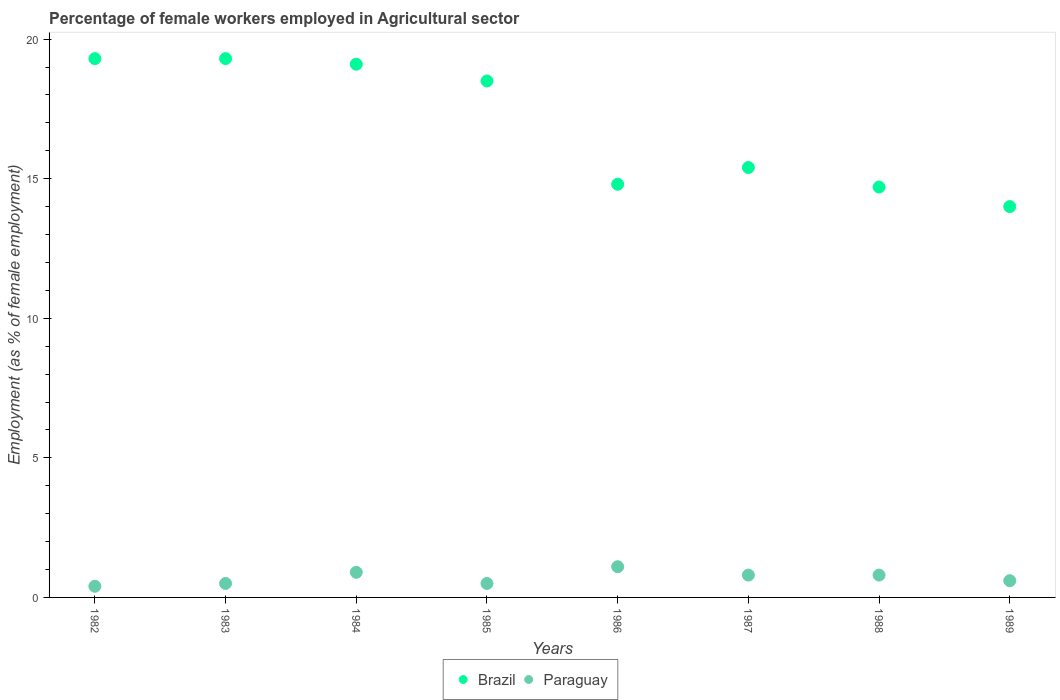How many different coloured dotlines are there?
Your response must be concise. 2. What is the percentage of females employed in Agricultural sector in Paraguay in 1985?
Keep it short and to the point. 0.5. Across all years, what is the maximum percentage of females employed in Agricultural sector in Paraguay?
Your answer should be compact. 1.1. Across all years, what is the minimum percentage of females employed in Agricultural sector in Paraguay?
Provide a short and direct response. 0.4. In which year was the percentage of females employed in Agricultural sector in Paraguay minimum?
Your answer should be compact. 1982. What is the total percentage of females employed in Agricultural sector in Paraguay in the graph?
Give a very brief answer. 5.6. What is the difference between the percentage of females employed in Agricultural sector in Paraguay in 1985 and that in 1988?
Ensure brevity in your answer.  -0.3. What is the difference between the percentage of females employed in Agricultural sector in Brazil in 1989 and the percentage of females employed in Agricultural sector in Paraguay in 1987?
Make the answer very short. 13.2. What is the average percentage of females employed in Agricultural sector in Paraguay per year?
Give a very brief answer. 0.7. In the year 1984, what is the difference between the percentage of females employed in Agricultural sector in Paraguay and percentage of females employed in Agricultural sector in Brazil?
Ensure brevity in your answer.  -18.2. In how many years, is the percentage of females employed in Agricultural sector in Brazil greater than 17 %?
Keep it short and to the point. 4. What is the ratio of the percentage of females employed in Agricultural sector in Paraguay in 1982 to that in 1985?
Offer a very short reply. 0.8. What is the difference between the highest and the second highest percentage of females employed in Agricultural sector in Paraguay?
Give a very brief answer. 0.2. What is the difference between the highest and the lowest percentage of females employed in Agricultural sector in Brazil?
Your answer should be very brief. 5.3. In how many years, is the percentage of females employed in Agricultural sector in Brazil greater than the average percentage of females employed in Agricultural sector in Brazil taken over all years?
Your answer should be compact. 4. Is the sum of the percentage of females employed in Agricultural sector in Brazil in 1984 and 1985 greater than the maximum percentage of females employed in Agricultural sector in Paraguay across all years?
Make the answer very short. Yes. What is the difference between two consecutive major ticks on the Y-axis?
Your response must be concise. 5. Does the graph contain any zero values?
Your response must be concise. No. Does the graph contain grids?
Provide a succinct answer. No. Where does the legend appear in the graph?
Make the answer very short. Bottom center. How are the legend labels stacked?
Your answer should be very brief. Horizontal. What is the title of the graph?
Provide a short and direct response. Percentage of female workers employed in Agricultural sector. What is the label or title of the X-axis?
Your answer should be very brief. Years. What is the label or title of the Y-axis?
Provide a succinct answer. Employment (as % of female employment). What is the Employment (as % of female employment) of Brazil in 1982?
Ensure brevity in your answer.  19.3. What is the Employment (as % of female employment) of Paraguay in 1982?
Offer a terse response. 0.4. What is the Employment (as % of female employment) of Brazil in 1983?
Make the answer very short. 19.3. What is the Employment (as % of female employment) of Paraguay in 1983?
Provide a succinct answer. 0.5. What is the Employment (as % of female employment) in Brazil in 1984?
Offer a very short reply. 19.1. What is the Employment (as % of female employment) in Paraguay in 1984?
Provide a short and direct response. 0.9. What is the Employment (as % of female employment) in Brazil in 1986?
Provide a short and direct response. 14.8. What is the Employment (as % of female employment) of Paraguay in 1986?
Your answer should be very brief. 1.1. What is the Employment (as % of female employment) of Brazil in 1987?
Offer a very short reply. 15.4. What is the Employment (as % of female employment) in Paraguay in 1987?
Give a very brief answer. 0.8. What is the Employment (as % of female employment) in Brazil in 1988?
Your response must be concise. 14.7. What is the Employment (as % of female employment) of Paraguay in 1988?
Provide a short and direct response. 0.8. What is the Employment (as % of female employment) in Brazil in 1989?
Ensure brevity in your answer.  14. What is the Employment (as % of female employment) of Paraguay in 1989?
Offer a very short reply. 0.6. Across all years, what is the maximum Employment (as % of female employment) in Brazil?
Offer a terse response. 19.3. Across all years, what is the maximum Employment (as % of female employment) of Paraguay?
Provide a succinct answer. 1.1. Across all years, what is the minimum Employment (as % of female employment) in Brazil?
Provide a succinct answer. 14. Across all years, what is the minimum Employment (as % of female employment) of Paraguay?
Your answer should be very brief. 0.4. What is the total Employment (as % of female employment) in Brazil in the graph?
Ensure brevity in your answer.  135.1. What is the difference between the Employment (as % of female employment) in Brazil in 1982 and that in 1983?
Keep it short and to the point. 0. What is the difference between the Employment (as % of female employment) in Paraguay in 1982 and that in 1983?
Your answer should be compact. -0.1. What is the difference between the Employment (as % of female employment) of Brazil in 1982 and that in 1984?
Your answer should be compact. 0.2. What is the difference between the Employment (as % of female employment) in Paraguay in 1982 and that in 1984?
Offer a very short reply. -0.5. What is the difference between the Employment (as % of female employment) of Brazil in 1982 and that in 1985?
Give a very brief answer. 0.8. What is the difference between the Employment (as % of female employment) of Paraguay in 1982 and that in 1985?
Keep it short and to the point. -0.1. What is the difference between the Employment (as % of female employment) in Paraguay in 1982 and that in 1986?
Your response must be concise. -0.7. What is the difference between the Employment (as % of female employment) of Brazil in 1982 and that in 1987?
Give a very brief answer. 3.9. What is the difference between the Employment (as % of female employment) of Brazil in 1982 and that in 1988?
Your response must be concise. 4.6. What is the difference between the Employment (as % of female employment) of Paraguay in 1982 and that in 1989?
Give a very brief answer. -0.2. What is the difference between the Employment (as % of female employment) of Brazil in 1983 and that in 1984?
Ensure brevity in your answer.  0.2. What is the difference between the Employment (as % of female employment) of Paraguay in 1983 and that in 1986?
Offer a very short reply. -0.6. What is the difference between the Employment (as % of female employment) in Brazil in 1983 and that in 1987?
Provide a short and direct response. 3.9. What is the difference between the Employment (as % of female employment) in Paraguay in 1983 and that in 1987?
Offer a very short reply. -0.3. What is the difference between the Employment (as % of female employment) of Brazil in 1984 and that in 1985?
Provide a succinct answer. 0.6. What is the difference between the Employment (as % of female employment) in Paraguay in 1984 and that in 1985?
Your answer should be very brief. 0.4. What is the difference between the Employment (as % of female employment) of Brazil in 1984 and that in 1986?
Give a very brief answer. 4.3. What is the difference between the Employment (as % of female employment) in Brazil in 1984 and that in 1989?
Give a very brief answer. 5.1. What is the difference between the Employment (as % of female employment) in Paraguay in 1984 and that in 1989?
Offer a very short reply. 0.3. What is the difference between the Employment (as % of female employment) in Paraguay in 1985 and that in 1987?
Make the answer very short. -0.3. What is the difference between the Employment (as % of female employment) of Brazil in 1985 and that in 1988?
Provide a succinct answer. 3.8. What is the difference between the Employment (as % of female employment) of Paraguay in 1985 and that in 1988?
Offer a very short reply. -0.3. What is the difference between the Employment (as % of female employment) in Brazil in 1985 and that in 1989?
Keep it short and to the point. 4.5. What is the difference between the Employment (as % of female employment) of Paraguay in 1986 and that in 1988?
Offer a very short reply. 0.3. What is the difference between the Employment (as % of female employment) in Brazil in 1986 and that in 1989?
Provide a succinct answer. 0.8. What is the difference between the Employment (as % of female employment) of Paraguay in 1986 and that in 1989?
Provide a short and direct response. 0.5. What is the difference between the Employment (as % of female employment) in Brazil in 1987 and that in 1988?
Your answer should be very brief. 0.7. What is the difference between the Employment (as % of female employment) of Brazil in 1987 and that in 1989?
Keep it short and to the point. 1.4. What is the difference between the Employment (as % of female employment) of Brazil in 1988 and that in 1989?
Offer a very short reply. 0.7. What is the difference between the Employment (as % of female employment) in Paraguay in 1988 and that in 1989?
Provide a succinct answer. 0.2. What is the difference between the Employment (as % of female employment) in Brazil in 1982 and the Employment (as % of female employment) in Paraguay in 1985?
Your response must be concise. 18.8. What is the difference between the Employment (as % of female employment) in Brazil in 1982 and the Employment (as % of female employment) in Paraguay in 1986?
Make the answer very short. 18.2. What is the difference between the Employment (as % of female employment) in Brazil in 1982 and the Employment (as % of female employment) in Paraguay in 1989?
Provide a short and direct response. 18.7. What is the difference between the Employment (as % of female employment) in Brazil in 1983 and the Employment (as % of female employment) in Paraguay in 1984?
Provide a succinct answer. 18.4. What is the difference between the Employment (as % of female employment) of Brazil in 1983 and the Employment (as % of female employment) of Paraguay in 1989?
Provide a short and direct response. 18.7. What is the difference between the Employment (as % of female employment) of Brazil in 1984 and the Employment (as % of female employment) of Paraguay in 1987?
Provide a short and direct response. 18.3. What is the difference between the Employment (as % of female employment) of Brazil in 1984 and the Employment (as % of female employment) of Paraguay in 1988?
Your response must be concise. 18.3. What is the difference between the Employment (as % of female employment) in Brazil in 1985 and the Employment (as % of female employment) in Paraguay in 1986?
Provide a succinct answer. 17.4. What is the difference between the Employment (as % of female employment) in Brazil in 1986 and the Employment (as % of female employment) in Paraguay in 1987?
Offer a terse response. 14. What is the difference between the Employment (as % of female employment) of Brazil in 1986 and the Employment (as % of female employment) of Paraguay in 1989?
Offer a very short reply. 14.2. What is the difference between the Employment (as % of female employment) in Brazil in 1987 and the Employment (as % of female employment) in Paraguay in 1988?
Provide a short and direct response. 14.6. What is the average Employment (as % of female employment) of Brazil per year?
Offer a very short reply. 16.89. What is the average Employment (as % of female employment) of Paraguay per year?
Give a very brief answer. 0.7. In the year 1982, what is the difference between the Employment (as % of female employment) of Brazil and Employment (as % of female employment) of Paraguay?
Make the answer very short. 18.9. In the year 1983, what is the difference between the Employment (as % of female employment) in Brazil and Employment (as % of female employment) in Paraguay?
Offer a terse response. 18.8. In the year 1984, what is the difference between the Employment (as % of female employment) in Brazil and Employment (as % of female employment) in Paraguay?
Offer a terse response. 18.2. In the year 1986, what is the difference between the Employment (as % of female employment) of Brazil and Employment (as % of female employment) of Paraguay?
Your answer should be very brief. 13.7. In the year 1987, what is the difference between the Employment (as % of female employment) of Brazil and Employment (as % of female employment) of Paraguay?
Ensure brevity in your answer.  14.6. In the year 1989, what is the difference between the Employment (as % of female employment) in Brazil and Employment (as % of female employment) in Paraguay?
Keep it short and to the point. 13.4. What is the ratio of the Employment (as % of female employment) of Brazil in 1982 to that in 1983?
Provide a short and direct response. 1. What is the ratio of the Employment (as % of female employment) in Brazil in 1982 to that in 1984?
Offer a very short reply. 1.01. What is the ratio of the Employment (as % of female employment) of Paraguay in 1982 to that in 1984?
Keep it short and to the point. 0.44. What is the ratio of the Employment (as % of female employment) of Brazil in 1982 to that in 1985?
Ensure brevity in your answer.  1.04. What is the ratio of the Employment (as % of female employment) of Paraguay in 1982 to that in 1985?
Your answer should be compact. 0.8. What is the ratio of the Employment (as % of female employment) of Brazil in 1982 to that in 1986?
Keep it short and to the point. 1.3. What is the ratio of the Employment (as % of female employment) in Paraguay in 1982 to that in 1986?
Offer a terse response. 0.36. What is the ratio of the Employment (as % of female employment) of Brazil in 1982 to that in 1987?
Make the answer very short. 1.25. What is the ratio of the Employment (as % of female employment) of Paraguay in 1982 to that in 1987?
Your response must be concise. 0.5. What is the ratio of the Employment (as % of female employment) in Brazil in 1982 to that in 1988?
Give a very brief answer. 1.31. What is the ratio of the Employment (as % of female employment) in Paraguay in 1982 to that in 1988?
Provide a short and direct response. 0.5. What is the ratio of the Employment (as % of female employment) in Brazil in 1982 to that in 1989?
Provide a succinct answer. 1.38. What is the ratio of the Employment (as % of female employment) of Paraguay in 1982 to that in 1989?
Offer a very short reply. 0.67. What is the ratio of the Employment (as % of female employment) in Brazil in 1983 to that in 1984?
Offer a very short reply. 1.01. What is the ratio of the Employment (as % of female employment) in Paraguay in 1983 to that in 1984?
Provide a short and direct response. 0.56. What is the ratio of the Employment (as % of female employment) of Brazil in 1983 to that in 1985?
Give a very brief answer. 1.04. What is the ratio of the Employment (as % of female employment) in Paraguay in 1983 to that in 1985?
Your response must be concise. 1. What is the ratio of the Employment (as % of female employment) in Brazil in 1983 to that in 1986?
Your answer should be compact. 1.3. What is the ratio of the Employment (as % of female employment) of Paraguay in 1983 to that in 1986?
Keep it short and to the point. 0.45. What is the ratio of the Employment (as % of female employment) of Brazil in 1983 to that in 1987?
Offer a very short reply. 1.25. What is the ratio of the Employment (as % of female employment) in Paraguay in 1983 to that in 1987?
Provide a succinct answer. 0.62. What is the ratio of the Employment (as % of female employment) in Brazil in 1983 to that in 1988?
Your answer should be very brief. 1.31. What is the ratio of the Employment (as % of female employment) in Paraguay in 1983 to that in 1988?
Keep it short and to the point. 0.62. What is the ratio of the Employment (as % of female employment) of Brazil in 1983 to that in 1989?
Offer a very short reply. 1.38. What is the ratio of the Employment (as % of female employment) in Paraguay in 1983 to that in 1989?
Your answer should be compact. 0.83. What is the ratio of the Employment (as % of female employment) in Brazil in 1984 to that in 1985?
Keep it short and to the point. 1.03. What is the ratio of the Employment (as % of female employment) in Paraguay in 1984 to that in 1985?
Give a very brief answer. 1.8. What is the ratio of the Employment (as % of female employment) of Brazil in 1984 to that in 1986?
Offer a very short reply. 1.29. What is the ratio of the Employment (as % of female employment) of Paraguay in 1984 to that in 1986?
Provide a succinct answer. 0.82. What is the ratio of the Employment (as % of female employment) in Brazil in 1984 to that in 1987?
Your answer should be compact. 1.24. What is the ratio of the Employment (as % of female employment) of Brazil in 1984 to that in 1988?
Provide a succinct answer. 1.3. What is the ratio of the Employment (as % of female employment) of Paraguay in 1984 to that in 1988?
Your answer should be very brief. 1.12. What is the ratio of the Employment (as % of female employment) in Brazil in 1984 to that in 1989?
Offer a very short reply. 1.36. What is the ratio of the Employment (as % of female employment) of Paraguay in 1984 to that in 1989?
Keep it short and to the point. 1.5. What is the ratio of the Employment (as % of female employment) of Brazil in 1985 to that in 1986?
Keep it short and to the point. 1.25. What is the ratio of the Employment (as % of female employment) of Paraguay in 1985 to that in 1986?
Offer a terse response. 0.45. What is the ratio of the Employment (as % of female employment) of Brazil in 1985 to that in 1987?
Your response must be concise. 1.2. What is the ratio of the Employment (as % of female employment) in Paraguay in 1985 to that in 1987?
Provide a short and direct response. 0.62. What is the ratio of the Employment (as % of female employment) in Brazil in 1985 to that in 1988?
Provide a short and direct response. 1.26. What is the ratio of the Employment (as % of female employment) in Brazil in 1985 to that in 1989?
Give a very brief answer. 1.32. What is the ratio of the Employment (as % of female employment) of Paraguay in 1985 to that in 1989?
Provide a succinct answer. 0.83. What is the ratio of the Employment (as % of female employment) of Paraguay in 1986 to that in 1987?
Make the answer very short. 1.38. What is the ratio of the Employment (as % of female employment) in Brazil in 1986 to that in 1988?
Offer a very short reply. 1.01. What is the ratio of the Employment (as % of female employment) in Paraguay in 1986 to that in 1988?
Your response must be concise. 1.38. What is the ratio of the Employment (as % of female employment) in Brazil in 1986 to that in 1989?
Keep it short and to the point. 1.06. What is the ratio of the Employment (as % of female employment) of Paraguay in 1986 to that in 1989?
Your answer should be compact. 1.83. What is the ratio of the Employment (as % of female employment) of Brazil in 1987 to that in 1988?
Ensure brevity in your answer.  1.05. What is the ratio of the Employment (as % of female employment) of Paraguay in 1987 to that in 1988?
Your response must be concise. 1. What is the ratio of the Employment (as % of female employment) of Paraguay in 1987 to that in 1989?
Your response must be concise. 1.33. What is the ratio of the Employment (as % of female employment) in Brazil in 1988 to that in 1989?
Your answer should be very brief. 1.05. What is the ratio of the Employment (as % of female employment) of Paraguay in 1988 to that in 1989?
Your answer should be compact. 1.33. What is the difference between the highest and the second highest Employment (as % of female employment) in Brazil?
Offer a very short reply. 0. What is the difference between the highest and the second highest Employment (as % of female employment) in Paraguay?
Your response must be concise. 0.2. What is the difference between the highest and the lowest Employment (as % of female employment) of Paraguay?
Offer a very short reply. 0.7. 